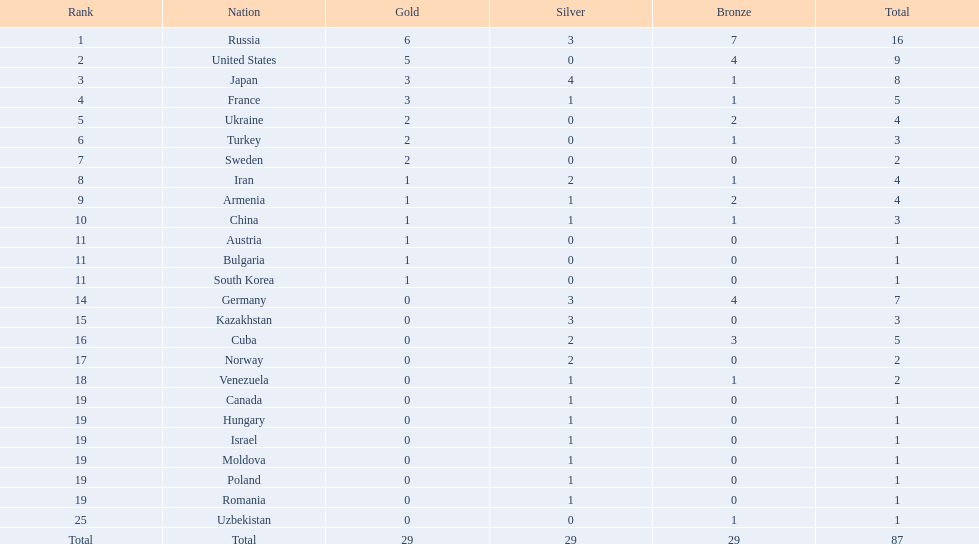Where did iran rank? 8. Where did germany rank? 14. Which of those did make it into the top 10 rank? Germany. 